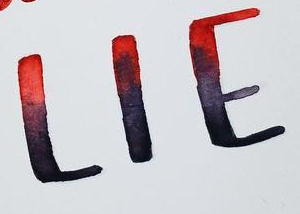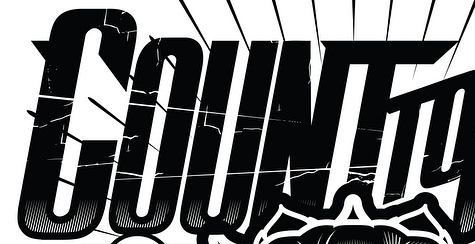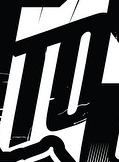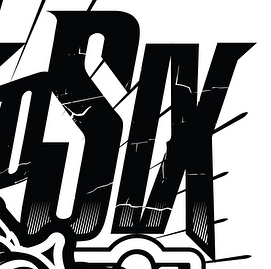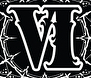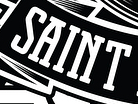What text appears in these images from left to right, separated by a semicolon? LIE; COUNT; TO; SIX; VI; SAINT 